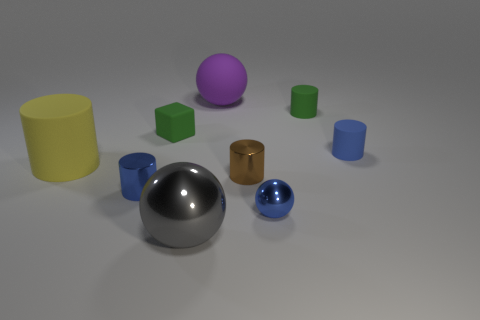Subtract all large yellow matte cylinders. How many cylinders are left? 4 Subtract all brown blocks. How many blue cylinders are left? 2 Subtract all gray balls. How many balls are left? 2 Subtract all cylinders. How many objects are left? 4 Subtract 1 cylinders. How many cylinders are left? 4 Add 4 yellow objects. How many yellow objects are left? 5 Add 9 large brown rubber blocks. How many large brown rubber blocks exist? 9 Subtract 0 yellow cubes. How many objects are left? 9 Subtract all purple cylinders. Subtract all gray cubes. How many cylinders are left? 5 Subtract all large gray matte objects. Subtract all large matte cylinders. How many objects are left? 8 